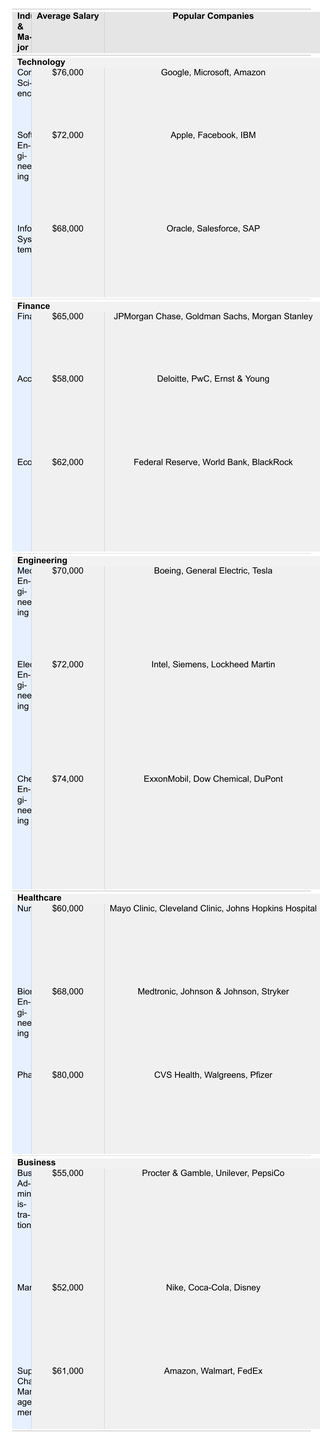What is the average starting salary for a Pharmacy major? According to the table, the average starting salary for a Pharmacy major is listed as $80,000.
Answer: $80,000 Which industry has the highest average starting salary for its majors? The highest average salary of $80,000 is from the Healthcare industry, specifically for the Pharmacy major.
Answer: Healthcare How much more does a Computer Science major earn compared to a Marketing major? The Computer Science major earns $76,000, while the Marketing major earns $52,000. The difference is $76,000 - $52,000 = $24,000.
Answer: $24,000 Are there any majors in Business that have an average starting salary above $60,000? The only major in Business with an average starting salary above $60,000 is Supply Chain Management, which has an average of $61,000.
Answer: Yes What is the average starting salary for Engineering majors? The average salaries for Engineering majors are $70,000 (Mechanical), $72,000 (Electrical), and $74,000 (Chemical). To find the average, we calculate (70,000 + 72,000 + 74,000) / 3 = $72,000.
Answer: $72,000 What major has the lowest starting salary in the table? The lowest starting salary listed in the table is for the Marketing major, with an average salary of $52,000.
Answer: Marketing Are salaries generally higher in Technology or Finance? The average salaries for Technology majors are $76,000 (Computer Science), $72,000 (Software Engineering), and $68,000 (Information Systems), which averages to $72,000. In Finance, the averages are $65,000 (Finance), $58,000 (Accounting), and $62,000 (Economics), averaging to $61,666. Therefore, salaries are higher in Technology.
Answer: Technology How many different majors in the Healthcare industry have an average salary greater than $65,000? In Healthcare, only Pharmacy ($80,000) and Biomedical Engineering ($68,000) have average salaries greater than $65,000, making a total of 2 majors.
Answer: 2 What is the average starting salary for majors in the Finance industry? The average starting salaries for Finance majors are $65,000 (Finance), $58,000 (Accounting), and $62,000 (Economics). The average is calculated as (65,000 + 58,000 + 62,000) / 3 = $61,666.
Answer: $61,666 Which major has the highest starting salary in the Engineering industry? The highest starting salary in Engineering is for Chemical Engineering, which has an average salary of $74,000.
Answer: Chemical Engineering 